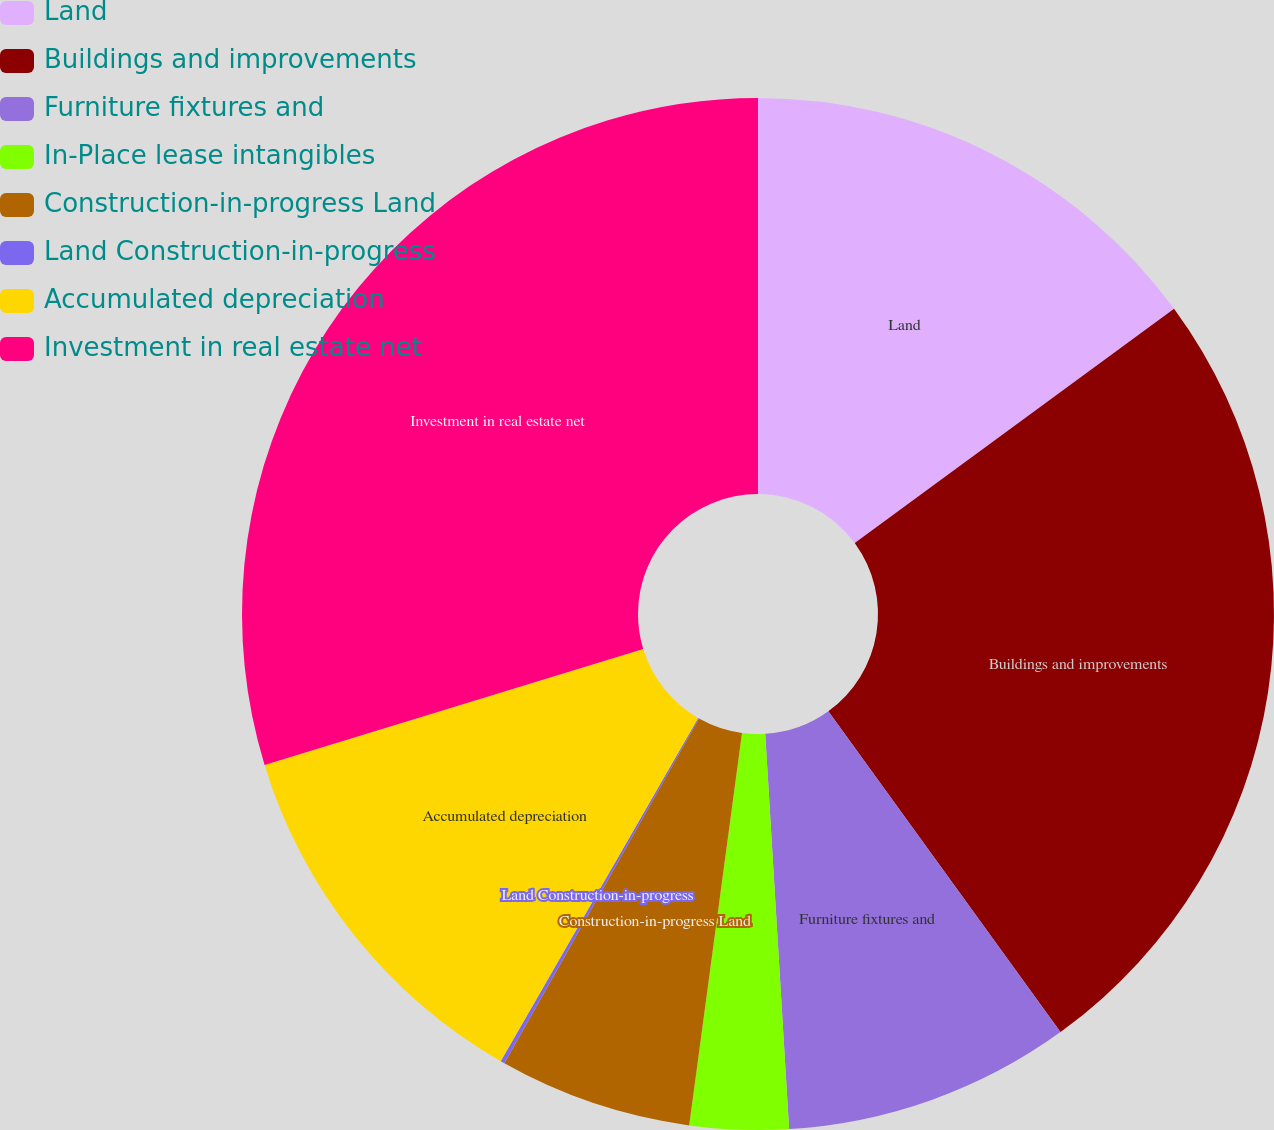Convert chart to OTSL. <chart><loc_0><loc_0><loc_500><loc_500><pie_chart><fcel>Land<fcel>Buildings and improvements<fcel>Furniture fixtures and<fcel>In-Place lease intangibles<fcel>Construction-in-progress Land<fcel>Land Construction-in-progress<fcel>Accumulated depreciation<fcel>Investment in real estate net<nl><fcel>14.93%<fcel>25.11%<fcel>9.01%<fcel>3.09%<fcel>6.05%<fcel>0.13%<fcel>11.97%<fcel>29.73%<nl></chart> 